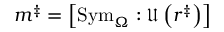Convert formula to latex. <formula><loc_0><loc_0><loc_500><loc_500>m ^ { \ddag } = \left [ S y m _ { \Omega } \colon \mathfrak { U } \left ( r ^ { \ddag } \right ) \right ]</formula> 